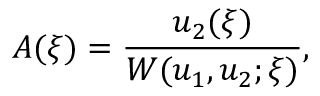<formula> <loc_0><loc_0><loc_500><loc_500>A ( \xi ) = { \frac { u _ { 2 } ( \xi ) } { W ( u _ { 1 } , u _ { 2 } ; \xi ) } } ,</formula> 